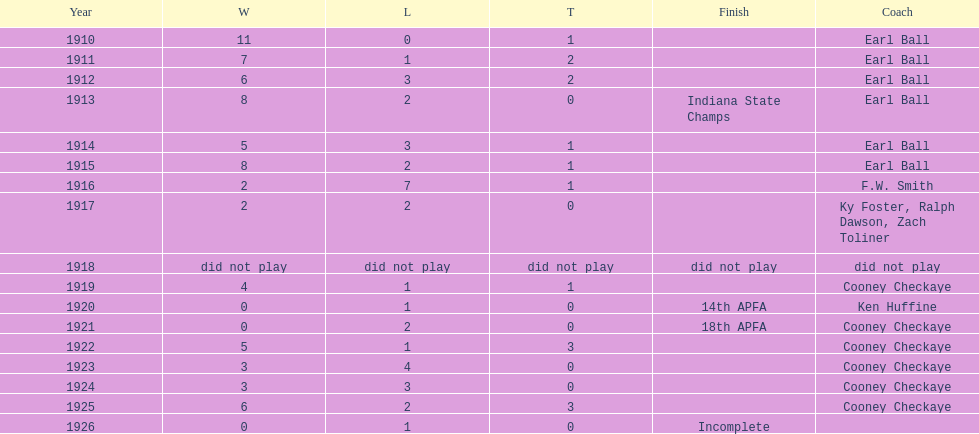The muncie flyers played from 1910 to 1925 in all but one of those years. which year did the flyers not play? 1918. 